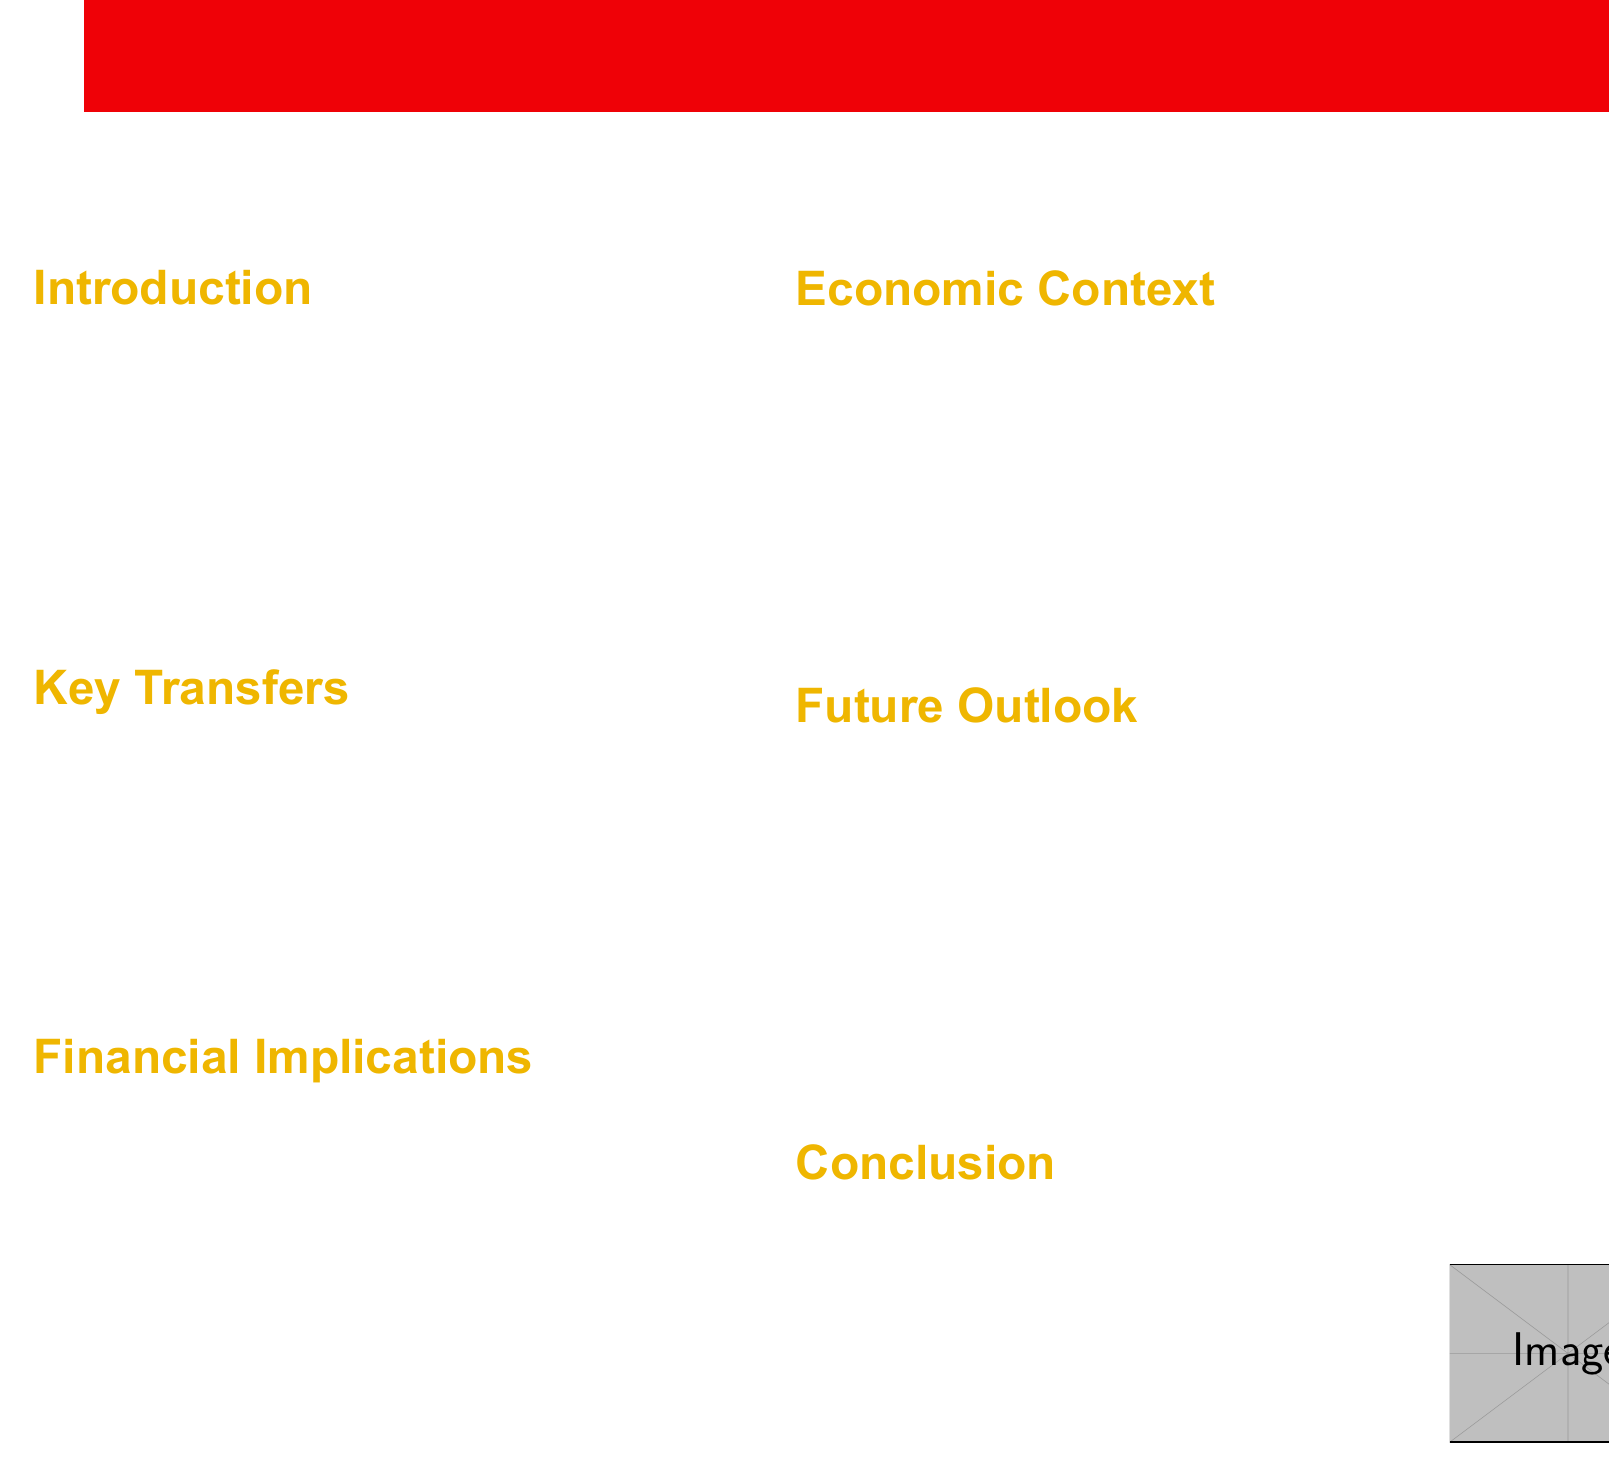What was the transfer fee for Declan Rice? The document states that Declan Rice was acquired for £105 million.
Answer: £105 million What is Arsenal's revenue for 2022? The revenue figure provided in the document for Arsenal in 2022 is £366 million.
Answer: £366 million Which club did Kai Havertz join Arsenal from? The document mentions that Kai Havertz was transferred from Chelsea.
Answer: Chelsea What is the potential impact of high-profile signings on Arsenal's wage bill? The document indicates that there will be an increased wage bill due to these signings.
Answer: Increased wage bill What is the purpose of Arsenal's focus on youth development? The document states that the club aims to balance high-cost transfers with nurturing young talents.
Answer: Balance high-cost transfers How much is the Premier League TV deal for the 2022-2025 cycle? The document provides the figure for the Premier League TV deal as £10.4 billion.
Answer: £10.4 billion What is a pressure point for Arsenal mentioned in the document? The document talks about the pressure to secure Champions League football to offset expenditure.
Answer: Champions League football What club's spending power is mentioned as trailing behind Arsenal? The document mentions that Arsenal's spending power trails behind Manchester City and Chelsea.
Answer: Manchester City and Chelsea 